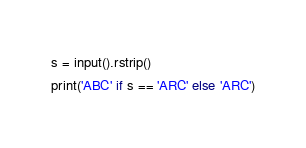<code> <loc_0><loc_0><loc_500><loc_500><_Python_>s = input().rstrip()
print('ABC' if s == 'ARC' else 'ARC')
</code> 